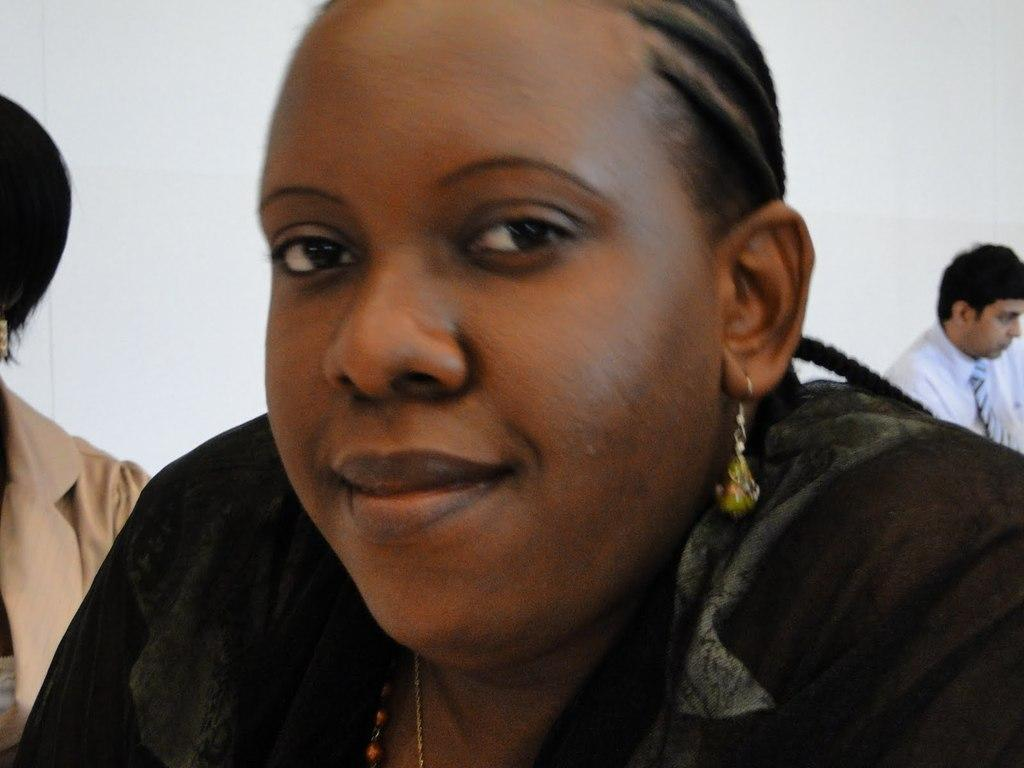Who is present in the image? There is a woman in the image. What is the woman's facial expression? The woman is smiling. What can be seen in the background of the image? There is a blazer, a man, and a wall in the background of the image. What type of ground can be seen in the image? There is no ground visible in the image; it appears to be an indoor setting with a wall in the background. 